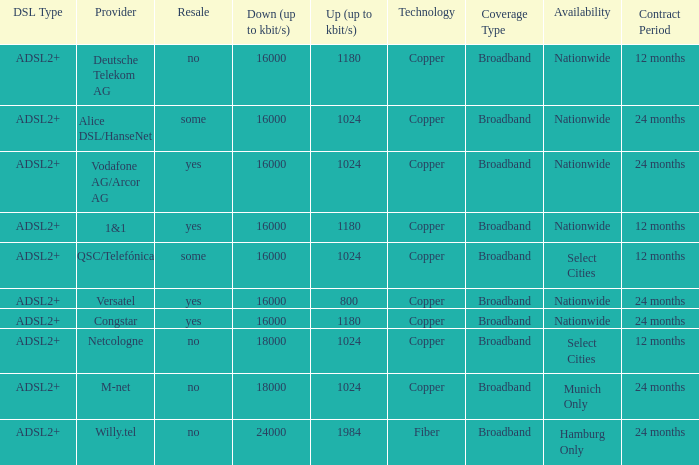How many providers are there where the resale category is yes and bandwith is up is 1024? 1.0. 